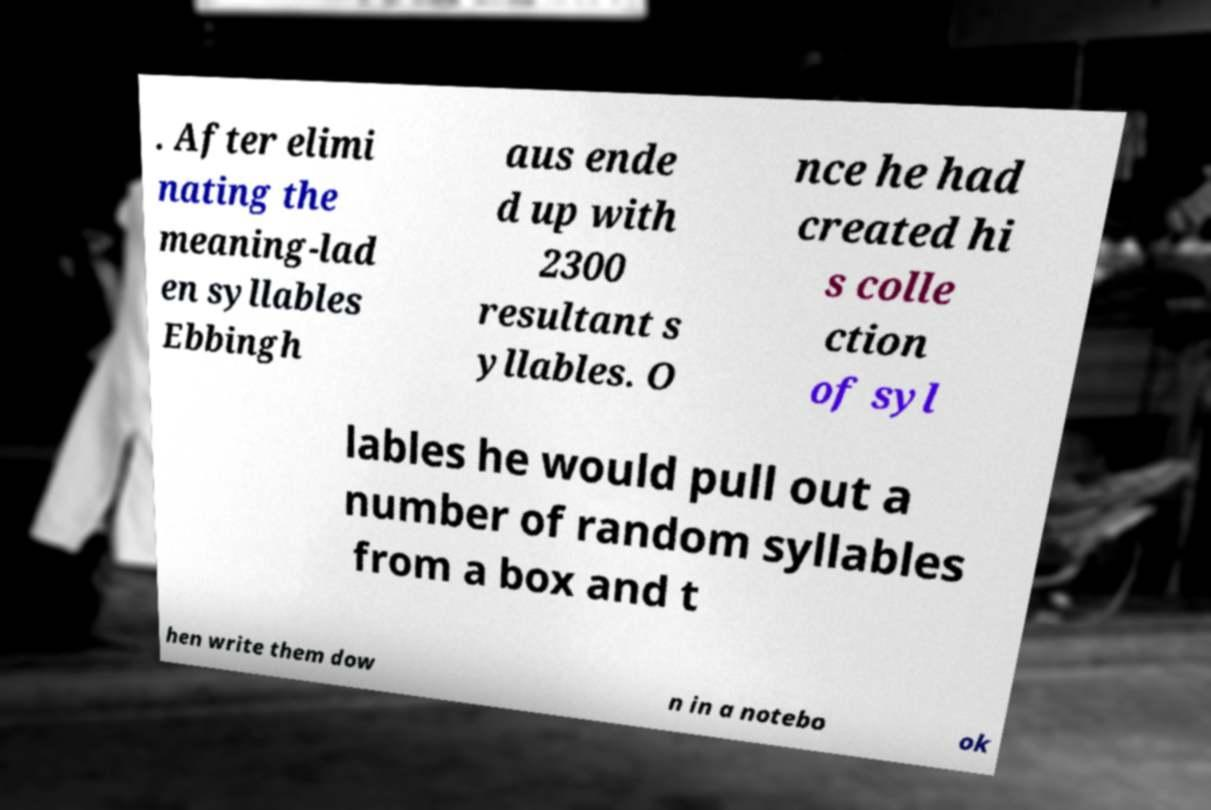Please identify and transcribe the text found in this image. . After elimi nating the meaning-lad en syllables Ebbingh aus ende d up with 2300 resultant s yllables. O nce he had created hi s colle ction of syl lables he would pull out a number of random syllables from a box and t hen write them dow n in a notebo ok 